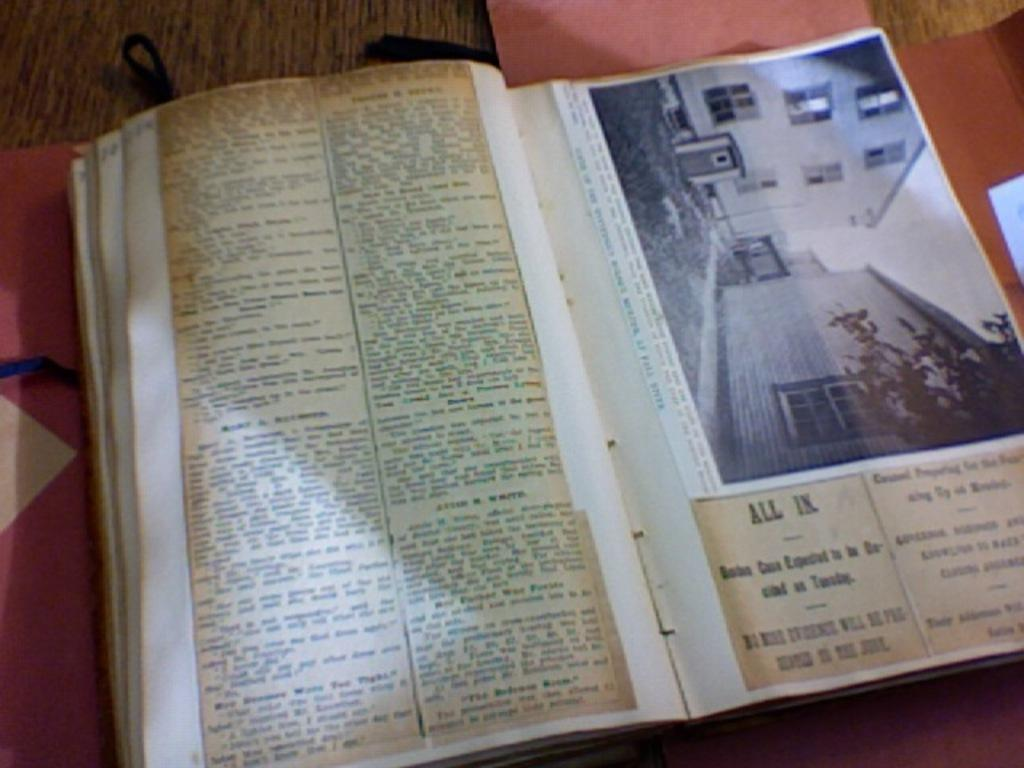<image>
Render a clear and concise summary of the photo. A scrapbook of newspaper clippings and photos includes the words "all in" as part of one of the headlines. 